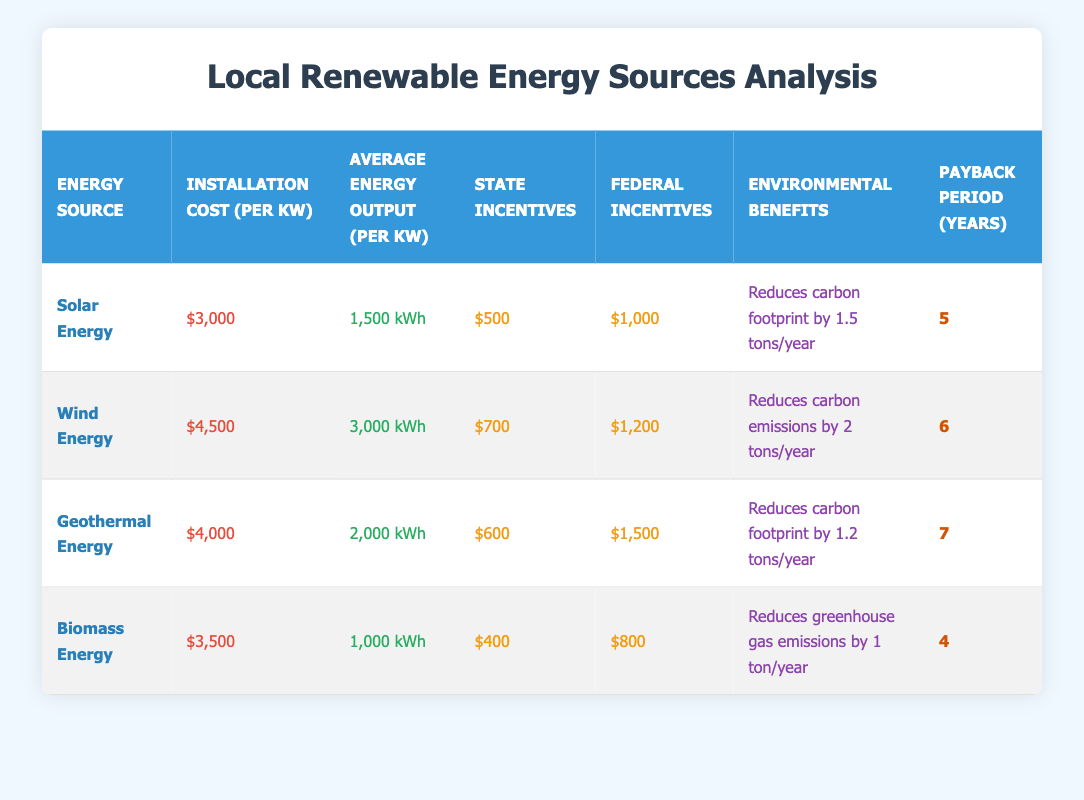What is the installation cost of Solar Energy? The table shows the installation cost per kW for various renewable energy sources. For Solar Energy, the corresponding value listed is $3,000.
Answer: $3,000 Which energy source has the highest average energy output per kW? By comparing the "Average Energy Output (per kW)" column for each energy source, Wind Energy has the highest value listed at 3,000 kWh.
Answer: Wind Energy What are the total federal incentives for Biomass Energy and Geothermal Energy combined? The federal incentives for Biomass Energy are $800 and for Geothermal Energy, they are $1,500. Adding these two values gives: 800 + 1500 = 2300.
Answer: $2,300 Does Geothermal Energy provide more environmental benefits compared to Biomass Energy? The table states that Geothermal Energy reduces the carbon footprint by 1.2 tons/year, while Biomass Energy reduces greenhouse gas emissions by 1 ton/year. Since 1.2 tons is greater than 1 ton, the statement is true.
Answer: Yes What is the average payback period for all listed renewable energy sources? To find the average payback period, we add the payback periods for each source: 5 (Solar) + 6 (Wind) + 7 (Geothermal) + 4 (Biomass) = 22. There are 4 sources, so we divide the total by 4: 22 / 4 = 5.5.
Answer: 5.5 